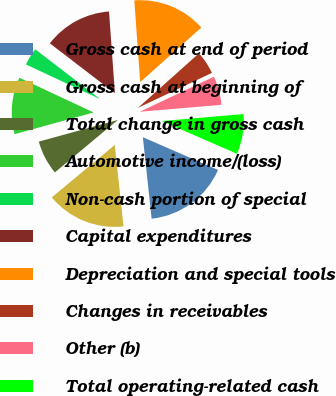Convert chart. <chart><loc_0><loc_0><loc_500><loc_500><pie_chart><fcel>Gross cash at end of period<fcel>Gross cash at beginning of<fcel>Total change in gross cash<fcel>Automotive income/(loss)<fcel>Non-cash portion of special<fcel>Capital expenditures<fcel>Depreciation and special tools<fcel>Changes in receivables<fcel>Other (b)<fcel>Total operating-related cash<nl><fcel>16.76%<fcel>15.65%<fcel>6.79%<fcel>11.22%<fcel>3.46%<fcel>13.44%<fcel>14.54%<fcel>4.57%<fcel>5.68%<fcel>7.89%<nl></chart> 